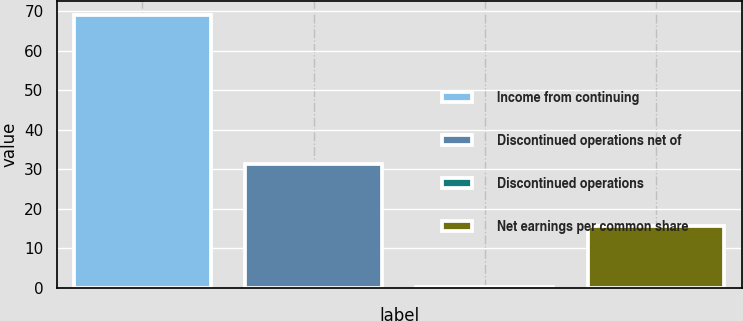<chart> <loc_0><loc_0><loc_500><loc_500><bar_chart><fcel>Income from continuing<fcel>Discontinued operations net of<fcel>Discontinued operations<fcel>Net earnings per common share<nl><fcel>69.1<fcel>31.44<fcel>0.1<fcel>15.77<nl></chart> 